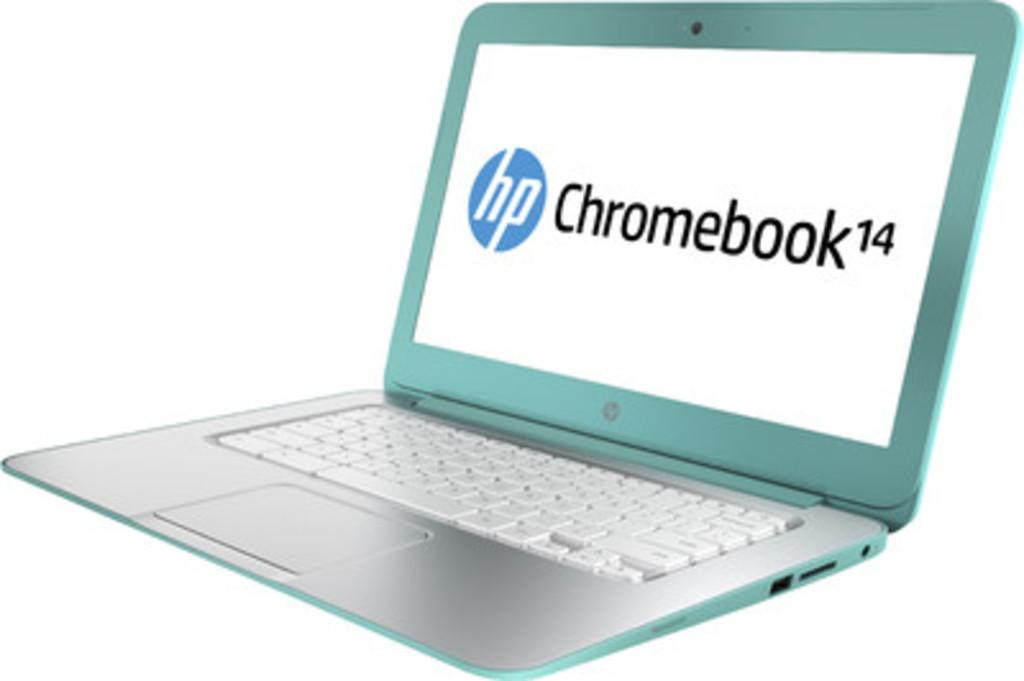Provide a one-sentence caption for the provided image. a green hp chromebook 14 with a white keyboard. 